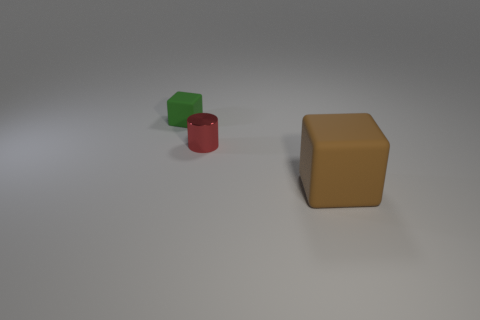Add 2 yellow shiny things. How many objects exist? 5 Subtract all green blocks. How many blocks are left? 1 Subtract all cylinders. How many objects are left? 2 Subtract 1 cylinders. How many cylinders are left? 0 Add 1 red metal things. How many red metal things are left? 2 Add 3 small red metallic cylinders. How many small red metallic cylinders exist? 4 Subtract 0 brown cylinders. How many objects are left? 3 Subtract all yellow blocks. Subtract all yellow cylinders. How many blocks are left? 2 Subtract all gray balls. How many red cubes are left? 0 Subtract all green spheres. Subtract all brown cubes. How many objects are left? 2 